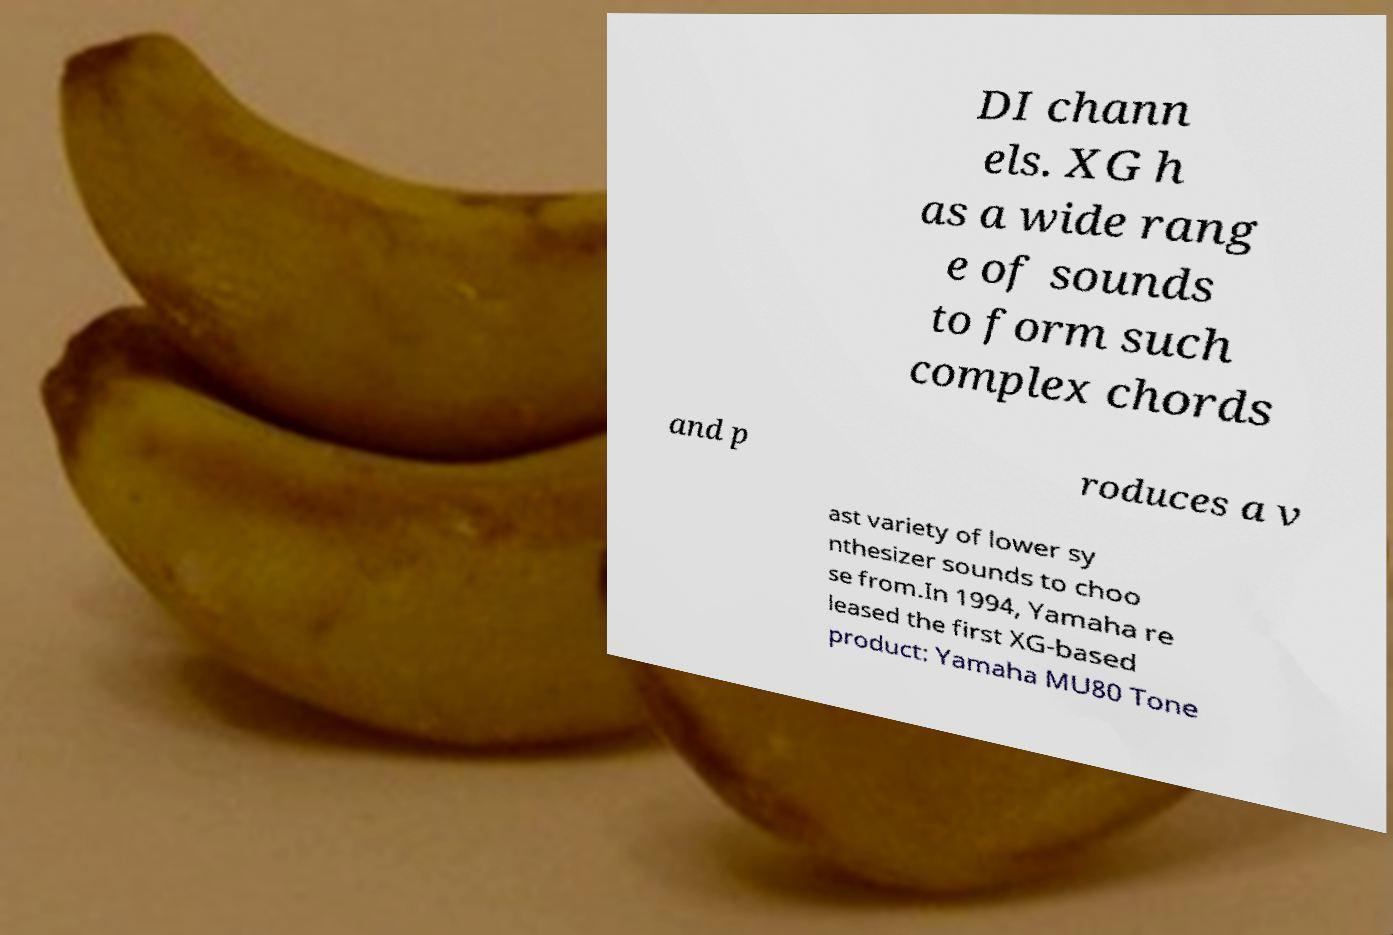What messages or text are displayed in this image? I need them in a readable, typed format. DI chann els. XG h as a wide rang e of sounds to form such complex chords and p roduces a v ast variety of lower sy nthesizer sounds to choo se from.In 1994, Yamaha re leased the first XG-based product: Yamaha MU80 Tone 